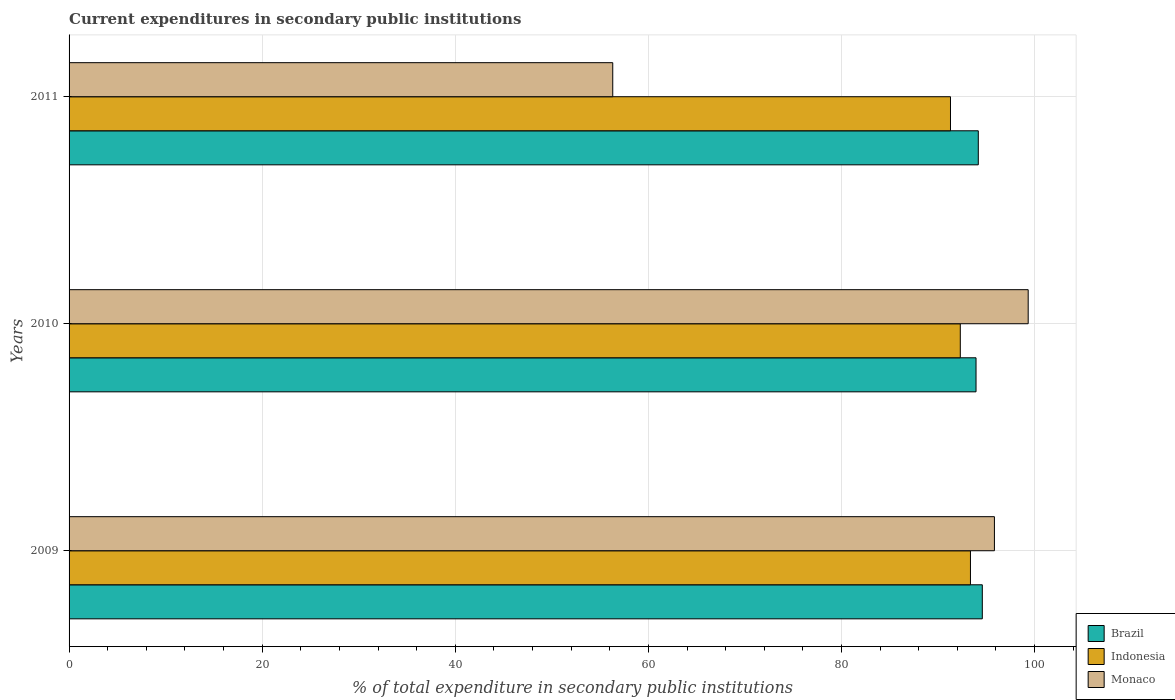How many different coloured bars are there?
Your answer should be very brief. 3. How many groups of bars are there?
Provide a succinct answer. 3. Are the number of bars per tick equal to the number of legend labels?
Give a very brief answer. Yes. Are the number of bars on each tick of the Y-axis equal?
Offer a very short reply. Yes. What is the label of the 2nd group of bars from the top?
Give a very brief answer. 2010. What is the current expenditures in secondary public institutions in Brazil in 2009?
Provide a succinct answer. 94.59. Across all years, what is the maximum current expenditures in secondary public institutions in Brazil?
Keep it short and to the point. 94.59. Across all years, what is the minimum current expenditures in secondary public institutions in Monaco?
Offer a terse response. 56.31. In which year was the current expenditures in secondary public institutions in Indonesia maximum?
Your answer should be very brief. 2009. What is the total current expenditures in secondary public institutions in Monaco in the graph?
Provide a succinct answer. 251.49. What is the difference between the current expenditures in secondary public institutions in Brazil in 2010 and that in 2011?
Ensure brevity in your answer.  -0.23. What is the difference between the current expenditures in secondary public institutions in Monaco in 2010 and the current expenditures in secondary public institutions in Brazil in 2011?
Your answer should be compact. 5.17. What is the average current expenditures in secondary public institutions in Indonesia per year?
Your response must be concise. 92.32. In the year 2011, what is the difference between the current expenditures in secondary public institutions in Brazil and current expenditures in secondary public institutions in Indonesia?
Ensure brevity in your answer.  2.88. What is the ratio of the current expenditures in secondary public institutions in Brazil in 2010 to that in 2011?
Your response must be concise. 1. Is the current expenditures in secondary public institutions in Monaco in 2009 less than that in 2010?
Keep it short and to the point. Yes. What is the difference between the highest and the second highest current expenditures in secondary public institutions in Monaco?
Give a very brief answer. 3.5. What is the difference between the highest and the lowest current expenditures in secondary public institutions in Indonesia?
Offer a terse response. 2.07. In how many years, is the current expenditures in secondary public institutions in Monaco greater than the average current expenditures in secondary public institutions in Monaco taken over all years?
Your response must be concise. 2. Is the sum of the current expenditures in secondary public institutions in Brazil in 2009 and 2010 greater than the maximum current expenditures in secondary public institutions in Indonesia across all years?
Your answer should be compact. Yes. What does the 3rd bar from the bottom in 2009 represents?
Offer a very short reply. Monaco. Is it the case that in every year, the sum of the current expenditures in secondary public institutions in Indonesia and current expenditures in secondary public institutions in Monaco is greater than the current expenditures in secondary public institutions in Brazil?
Offer a terse response. Yes. Are the values on the major ticks of X-axis written in scientific E-notation?
Keep it short and to the point. No. Does the graph contain any zero values?
Provide a succinct answer. No. Where does the legend appear in the graph?
Offer a terse response. Bottom right. How are the legend labels stacked?
Keep it short and to the point. Vertical. What is the title of the graph?
Your answer should be very brief. Current expenditures in secondary public institutions. What is the label or title of the X-axis?
Make the answer very short. % of total expenditure in secondary public institutions. What is the label or title of the Y-axis?
Provide a succinct answer. Years. What is the % of total expenditure in secondary public institutions in Brazil in 2009?
Give a very brief answer. 94.59. What is the % of total expenditure in secondary public institutions of Indonesia in 2009?
Keep it short and to the point. 93.36. What is the % of total expenditure in secondary public institutions of Monaco in 2009?
Offer a very short reply. 95.84. What is the % of total expenditure in secondary public institutions in Brazil in 2010?
Make the answer very short. 93.94. What is the % of total expenditure in secondary public institutions of Indonesia in 2010?
Offer a terse response. 92.31. What is the % of total expenditure in secondary public institutions of Monaco in 2010?
Your answer should be compact. 99.34. What is the % of total expenditure in secondary public institutions of Brazil in 2011?
Give a very brief answer. 94.17. What is the % of total expenditure in secondary public institutions of Indonesia in 2011?
Make the answer very short. 91.29. What is the % of total expenditure in secondary public institutions of Monaco in 2011?
Provide a short and direct response. 56.31. Across all years, what is the maximum % of total expenditure in secondary public institutions in Brazil?
Your response must be concise. 94.59. Across all years, what is the maximum % of total expenditure in secondary public institutions in Indonesia?
Offer a very short reply. 93.36. Across all years, what is the maximum % of total expenditure in secondary public institutions in Monaco?
Your answer should be very brief. 99.34. Across all years, what is the minimum % of total expenditure in secondary public institutions in Brazil?
Make the answer very short. 93.94. Across all years, what is the minimum % of total expenditure in secondary public institutions in Indonesia?
Offer a very short reply. 91.29. Across all years, what is the minimum % of total expenditure in secondary public institutions in Monaco?
Give a very brief answer. 56.31. What is the total % of total expenditure in secondary public institutions in Brazil in the graph?
Make the answer very short. 282.69. What is the total % of total expenditure in secondary public institutions of Indonesia in the graph?
Make the answer very short. 276.96. What is the total % of total expenditure in secondary public institutions of Monaco in the graph?
Provide a short and direct response. 251.49. What is the difference between the % of total expenditure in secondary public institutions in Brazil in 2009 and that in 2010?
Offer a terse response. 0.65. What is the difference between the % of total expenditure in secondary public institutions of Indonesia in 2009 and that in 2010?
Offer a very short reply. 1.05. What is the difference between the % of total expenditure in secondary public institutions of Monaco in 2009 and that in 2010?
Provide a short and direct response. -3.5. What is the difference between the % of total expenditure in secondary public institutions in Brazil in 2009 and that in 2011?
Offer a very short reply. 0.42. What is the difference between the % of total expenditure in secondary public institutions in Indonesia in 2009 and that in 2011?
Your response must be concise. 2.07. What is the difference between the % of total expenditure in secondary public institutions of Monaco in 2009 and that in 2011?
Ensure brevity in your answer.  39.53. What is the difference between the % of total expenditure in secondary public institutions in Brazil in 2010 and that in 2011?
Your answer should be compact. -0.23. What is the difference between the % of total expenditure in secondary public institutions of Indonesia in 2010 and that in 2011?
Offer a terse response. 1.02. What is the difference between the % of total expenditure in secondary public institutions in Monaco in 2010 and that in 2011?
Offer a very short reply. 43.03. What is the difference between the % of total expenditure in secondary public institutions in Brazil in 2009 and the % of total expenditure in secondary public institutions in Indonesia in 2010?
Keep it short and to the point. 2.28. What is the difference between the % of total expenditure in secondary public institutions of Brazil in 2009 and the % of total expenditure in secondary public institutions of Monaco in 2010?
Keep it short and to the point. -4.75. What is the difference between the % of total expenditure in secondary public institutions of Indonesia in 2009 and the % of total expenditure in secondary public institutions of Monaco in 2010?
Your answer should be very brief. -5.98. What is the difference between the % of total expenditure in secondary public institutions of Brazil in 2009 and the % of total expenditure in secondary public institutions of Indonesia in 2011?
Your answer should be very brief. 3.3. What is the difference between the % of total expenditure in secondary public institutions in Brazil in 2009 and the % of total expenditure in secondary public institutions in Monaco in 2011?
Your response must be concise. 38.28. What is the difference between the % of total expenditure in secondary public institutions of Indonesia in 2009 and the % of total expenditure in secondary public institutions of Monaco in 2011?
Provide a succinct answer. 37.05. What is the difference between the % of total expenditure in secondary public institutions in Brazil in 2010 and the % of total expenditure in secondary public institutions in Indonesia in 2011?
Your response must be concise. 2.65. What is the difference between the % of total expenditure in secondary public institutions of Brazil in 2010 and the % of total expenditure in secondary public institutions of Monaco in 2011?
Your answer should be compact. 37.63. What is the difference between the % of total expenditure in secondary public institutions of Indonesia in 2010 and the % of total expenditure in secondary public institutions of Monaco in 2011?
Provide a succinct answer. 36. What is the average % of total expenditure in secondary public institutions of Brazil per year?
Make the answer very short. 94.23. What is the average % of total expenditure in secondary public institutions in Indonesia per year?
Make the answer very short. 92.32. What is the average % of total expenditure in secondary public institutions of Monaco per year?
Give a very brief answer. 83.83. In the year 2009, what is the difference between the % of total expenditure in secondary public institutions of Brazil and % of total expenditure in secondary public institutions of Indonesia?
Provide a short and direct response. 1.23. In the year 2009, what is the difference between the % of total expenditure in secondary public institutions of Brazil and % of total expenditure in secondary public institutions of Monaco?
Provide a short and direct response. -1.25. In the year 2009, what is the difference between the % of total expenditure in secondary public institutions in Indonesia and % of total expenditure in secondary public institutions in Monaco?
Provide a succinct answer. -2.48. In the year 2010, what is the difference between the % of total expenditure in secondary public institutions of Brazil and % of total expenditure in secondary public institutions of Indonesia?
Give a very brief answer. 1.63. In the year 2010, what is the difference between the % of total expenditure in secondary public institutions of Brazil and % of total expenditure in secondary public institutions of Monaco?
Give a very brief answer. -5.4. In the year 2010, what is the difference between the % of total expenditure in secondary public institutions in Indonesia and % of total expenditure in secondary public institutions in Monaco?
Make the answer very short. -7.03. In the year 2011, what is the difference between the % of total expenditure in secondary public institutions of Brazil and % of total expenditure in secondary public institutions of Indonesia?
Offer a terse response. 2.88. In the year 2011, what is the difference between the % of total expenditure in secondary public institutions in Brazil and % of total expenditure in secondary public institutions in Monaco?
Offer a terse response. 37.86. In the year 2011, what is the difference between the % of total expenditure in secondary public institutions in Indonesia and % of total expenditure in secondary public institutions in Monaco?
Give a very brief answer. 34.98. What is the ratio of the % of total expenditure in secondary public institutions of Brazil in 2009 to that in 2010?
Make the answer very short. 1.01. What is the ratio of the % of total expenditure in secondary public institutions in Indonesia in 2009 to that in 2010?
Your answer should be compact. 1.01. What is the ratio of the % of total expenditure in secondary public institutions in Monaco in 2009 to that in 2010?
Provide a succinct answer. 0.96. What is the ratio of the % of total expenditure in secondary public institutions in Indonesia in 2009 to that in 2011?
Offer a very short reply. 1.02. What is the ratio of the % of total expenditure in secondary public institutions of Monaco in 2009 to that in 2011?
Ensure brevity in your answer.  1.7. What is the ratio of the % of total expenditure in secondary public institutions of Brazil in 2010 to that in 2011?
Provide a succinct answer. 1. What is the ratio of the % of total expenditure in secondary public institutions in Indonesia in 2010 to that in 2011?
Provide a short and direct response. 1.01. What is the ratio of the % of total expenditure in secondary public institutions of Monaco in 2010 to that in 2011?
Provide a short and direct response. 1.76. What is the difference between the highest and the second highest % of total expenditure in secondary public institutions of Brazil?
Make the answer very short. 0.42. What is the difference between the highest and the second highest % of total expenditure in secondary public institutions of Indonesia?
Make the answer very short. 1.05. What is the difference between the highest and the second highest % of total expenditure in secondary public institutions in Monaco?
Ensure brevity in your answer.  3.5. What is the difference between the highest and the lowest % of total expenditure in secondary public institutions in Brazil?
Provide a short and direct response. 0.65. What is the difference between the highest and the lowest % of total expenditure in secondary public institutions of Indonesia?
Provide a short and direct response. 2.07. What is the difference between the highest and the lowest % of total expenditure in secondary public institutions in Monaco?
Offer a terse response. 43.03. 